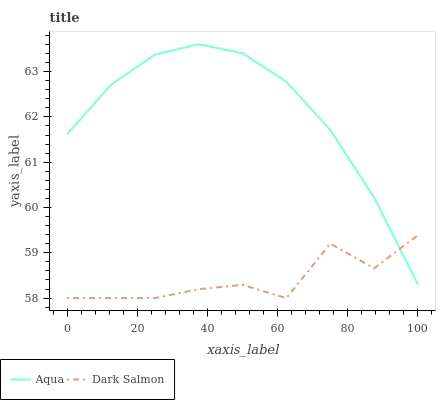Does Dark Salmon have the minimum area under the curve?
Answer yes or no. Yes. Does Aqua have the maximum area under the curve?
Answer yes or no. Yes. Does Dark Salmon have the maximum area under the curve?
Answer yes or no. No. Is Aqua the smoothest?
Answer yes or no. Yes. Is Dark Salmon the roughest?
Answer yes or no. Yes. Is Dark Salmon the smoothest?
Answer yes or no. No. Does Dark Salmon have the lowest value?
Answer yes or no. Yes. Does Aqua have the highest value?
Answer yes or no. Yes. Does Dark Salmon have the highest value?
Answer yes or no. No. Does Dark Salmon intersect Aqua?
Answer yes or no. Yes. Is Dark Salmon less than Aqua?
Answer yes or no. No. Is Dark Salmon greater than Aqua?
Answer yes or no. No. 